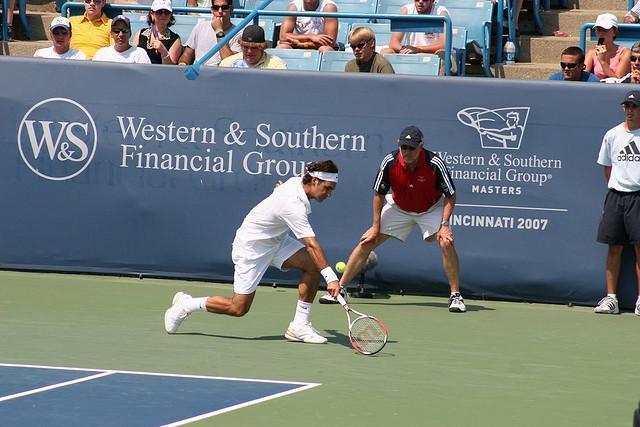When was the advertised company founded?
Select the accurate answer and provide justification: `Answer: choice
Rationale: srationale.`
Options: 2000, 1990, 2007, 1888. Answer: 1888.
Rationale: The advertised company on the wall in the background is called western and southern financial group.  they were founded in 1888 but sponsored a tennis tourney in 2007. 